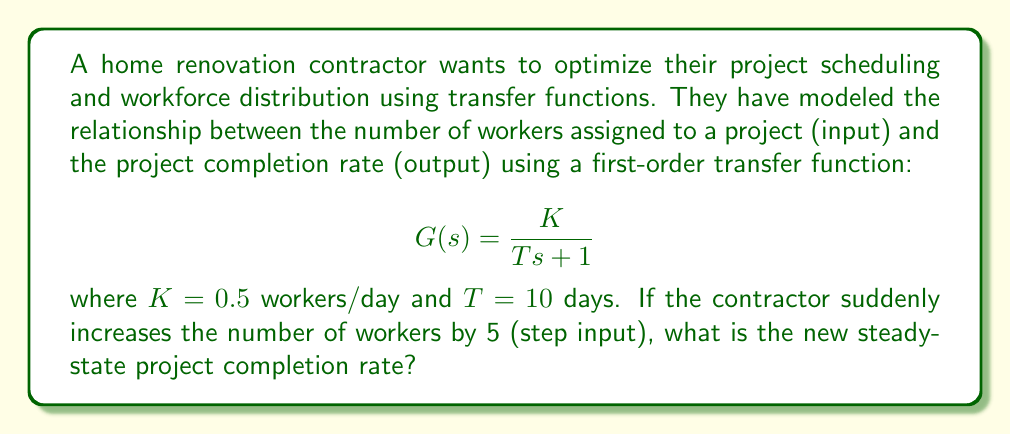Show me your answer to this math problem. To solve this problem, we'll follow these steps:

1) The transfer function $G(s)$ relates the input (number of workers) to the output (project completion rate) in the Laplace domain.

2) For a step input of magnitude 5, the Laplace transform is:

   $$U(s) = \frac{5}{s}$$

3) The output in the Laplace domain is the product of the input and the transfer function:

   $$Y(s) = G(s) \cdot U(s) = \frac{K}{Ts + 1} \cdot \frac{5}{s}$$

4) Substituting the given values:

   $$Y(s) = \frac{0.5}{10s + 1} \cdot \frac{5}{s} = \frac{2.5}{s(10s + 1)}$$

5) To find the steady-state value, we use the Final Value Theorem:

   $$\lim_{t \to \infty} y(t) = \lim_{s \to 0} sY(s)$$

6) Applying this to our function:

   $$\lim_{s \to 0} s \cdot \frac{2.5}{s(10s + 1)} = \lim_{s \to 0} \frac{2.5}{10s + 1} = \frac{2.5}{1} = 2.5$$

Therefore, the new steady-state project completion rate is 2.5 projects/day.
Answer: 2.5 projects/day 